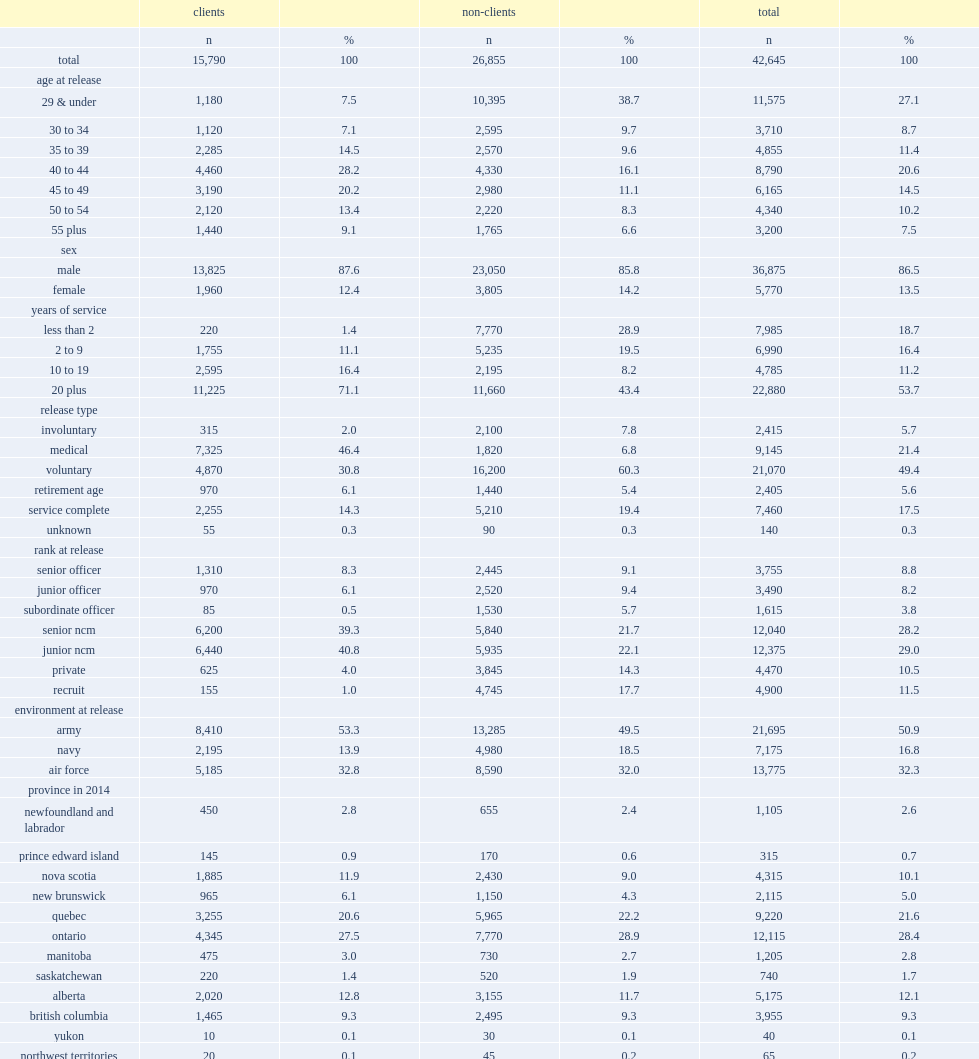What is the percentage point of the regular force cohort of this study population were male? 86.5. What is the percentage point of the cohort were also 30 years of age or older? 72.9. What is the percentage point of the cohort had served 20 years or more? 53.7. What is the percentage point of the cohort were junior and senior non-commissioned members at release? 57.2. What is the percentage point of the cohort were not clients of vac? 0.629734. 